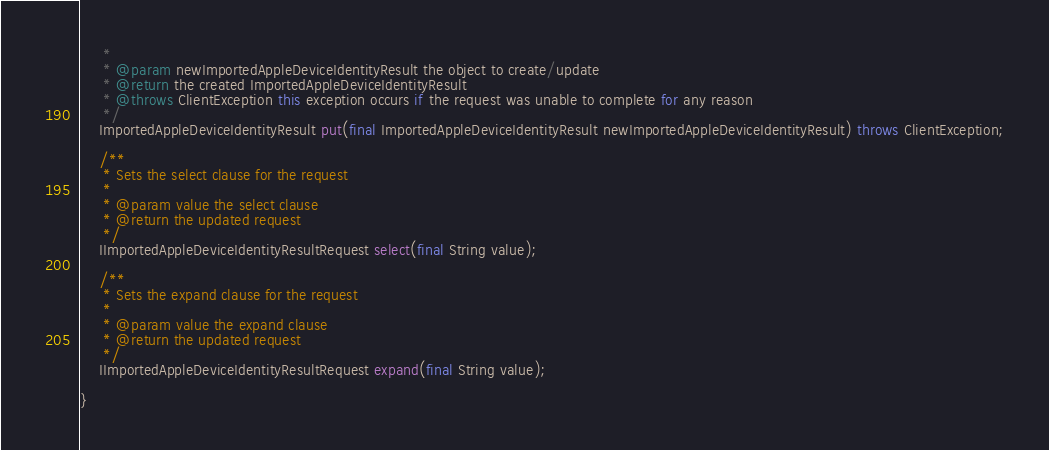<code> <loc_0><loc_0><loc_500><loc_500><_Java_>     *
     * @param newImportedAppleDeviceIdentityResult the object to create/update
     * @return the created ImportedAppleDeviceIdentityResult
     * @throws ClientException this exception occurs if the request was unable to complete for any reason
     */
    ImportedAppleDeviceIdentityResult put(final ImportedAppleDeviceIdentityResult newImportedAppleDeviceIdentityResult) throws ClientException;

    /**
     * Sets the select clause for the request
     *
     * @param value the select clause
     * @return the updated request
     */
    IImportedAppleDeviceIdentityResultRequest select(final String value);

    /**
     * Sets the expand clause for the request
     *
     * @param value the expand clause
     * @return the updated request
     */
    IImportedAppleDeviceIdentityResultRequest expand(final String value);

}

</code> 